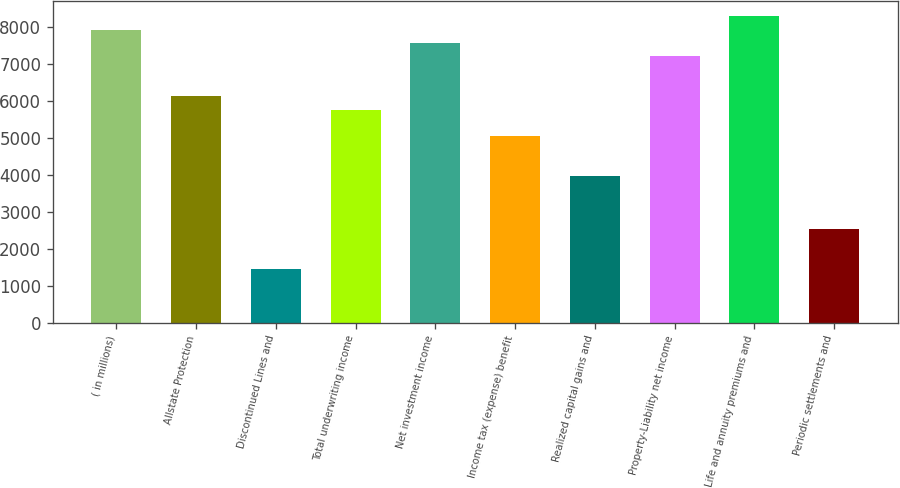Convert chart to OTSL. <chart><loc_0><loc_0><loc_500><loc_500><bar_chart><fcel>( in millions)<fcel>Allstate Protection<fcel>Discontinued Lines and<fcel>Total underwriting income<fcel>Net investment income<fcel>Income tax (expense) benefit<fcel>Realized capital gains and<fcel>Property-Liability net income<fcel>Life and annuity premiums and<fcel>Periodic settlements and<nl><fcel>7937.8<fcel>6135.8<fcel>1450.6<fcel>5775.4<fcel>7577.4<fcel>5054.6<fcel>3973.4<fcel>7217<fcel>8298.2<fcel>2531.8<nl></chart> 